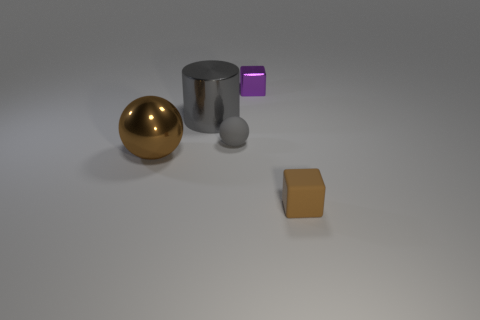How big is the block that is behind the big metallic thing that is in front of the tiny gray thing?
Make the answer very short. Small. Is there anything else that has the same color as the large metal ball?
Ensure brevity in your answer.  Yes. Is the material of the cube behind the small brown rubber block the same as the gray cylinder behind the big metallic ball?
Provide a succinct answer. Yes. What is the thing that is both in front of the tiny matte sphere and right of the gray metallic object made of?
Ensure brevity in your answer.  Rubber. There is a small gray rubber thing; is its shape the same as the brown thing that is on the left side of the metallic cylinder?
Provide a short and direct response. Yes. There is a block behind the small object that is left of the purple metallic block behind the tiny gray matte object; what is its material?
Your answer should be very brief. Metal. How many other things are there of the same size as the brown rubber cube?
Offer a terse response. 2. Is the color of the small rubber cube the same as the small metal cube?
Offer a very short reply. No. What number of tiny objects are right of the metal object to the right of the large metallic thing to the right of the metallic sphere?
Offer a terse response. 1. The gray sphere on the right side of the big thing in front of the gray sphere is made of what material?
Offer a terse response. Rubber. 